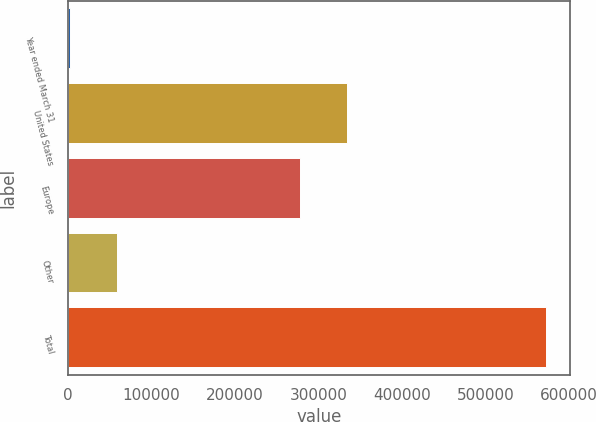Convert chart. <chart><loc_0><loc_0><loc_500><loc_500><bar_chart><fcel>Year ended March 31<fcel>United States<fcel>Europe<fcel>Other<fcel>Total<nl><fcel>2000<fcel>334506<fcel>277485<fcel>59020.5<fcel>572205<nl></chart> 